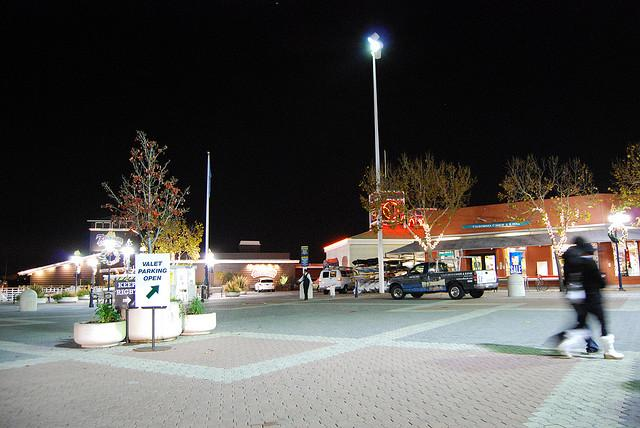What fast food restaurant is seen in the background? Please explain your reasoning. mcdonald's. The restaurant is mcdonald's. 